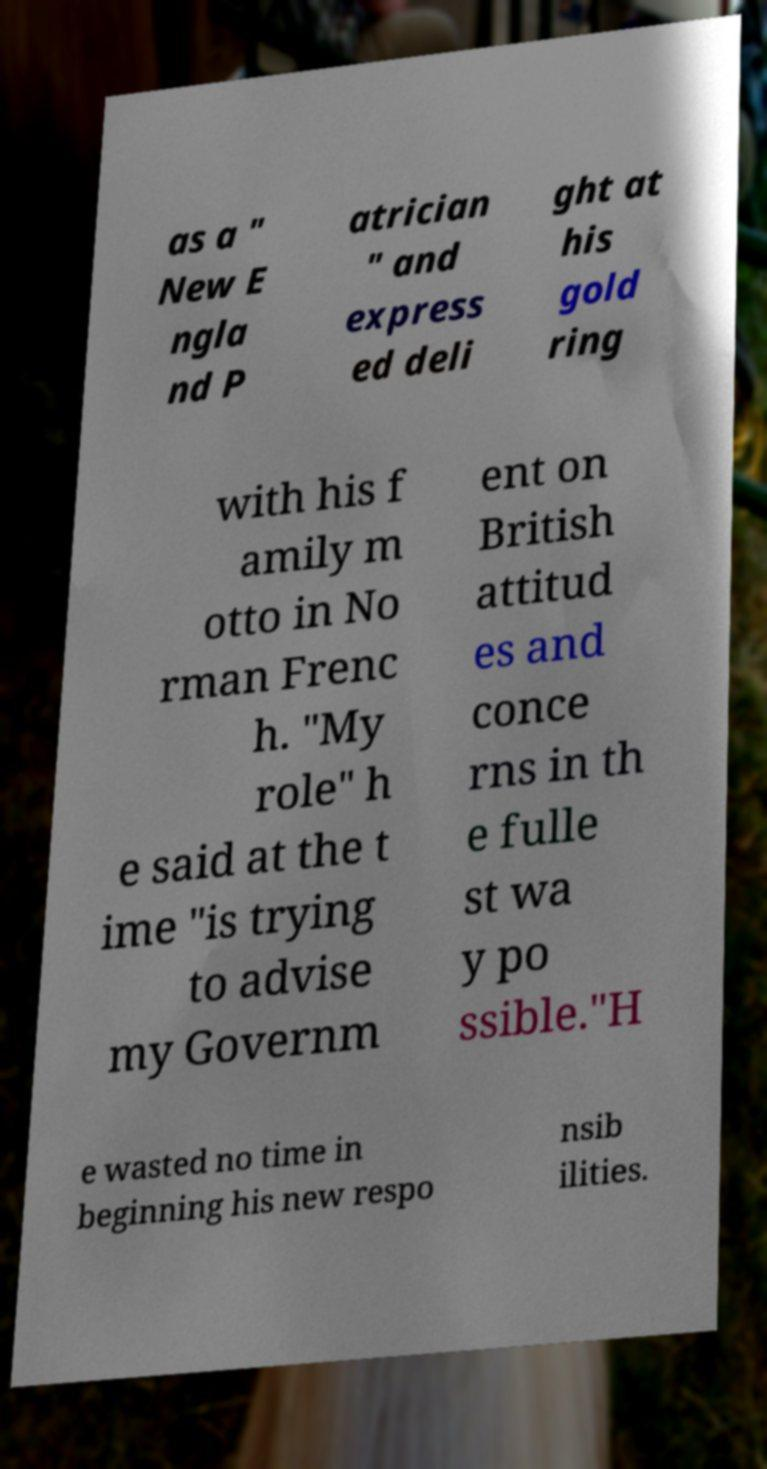Could you assist in decoding the text presented in this image and type it out clearly? as a " New E ngla nd P atrician " and express ed deli ght at his gold ring with his f amily m otto in No rman Frenc h. "My role" h e said at the t ime "is trying to advise my Governm ent on British attitud es and conce rns in th e fulle st wa y po ssible."H e wasted no time in beginning his new respo nsib ilities. 